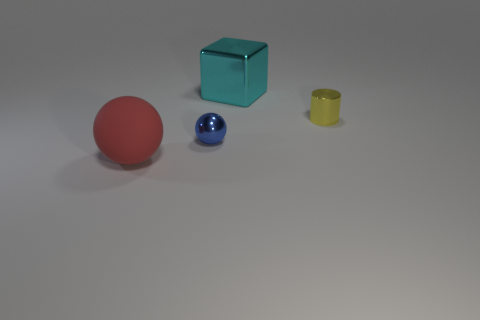Do these objects have any reflective surfaces? Indeed, the blue sphere and the teal cube have reflective surfaces, as indicated by the light highlights and the visible reflections on their exteriors. 